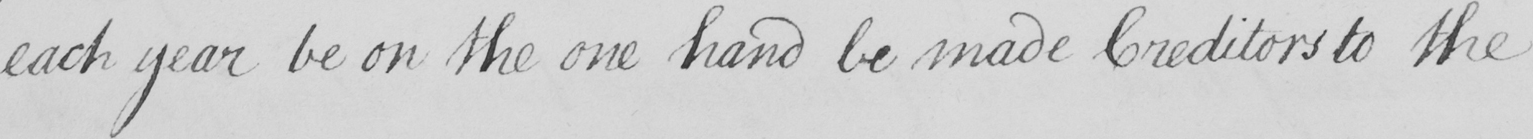What text is written in this handwritten line? each year be on the one hand be made Creditors to the 